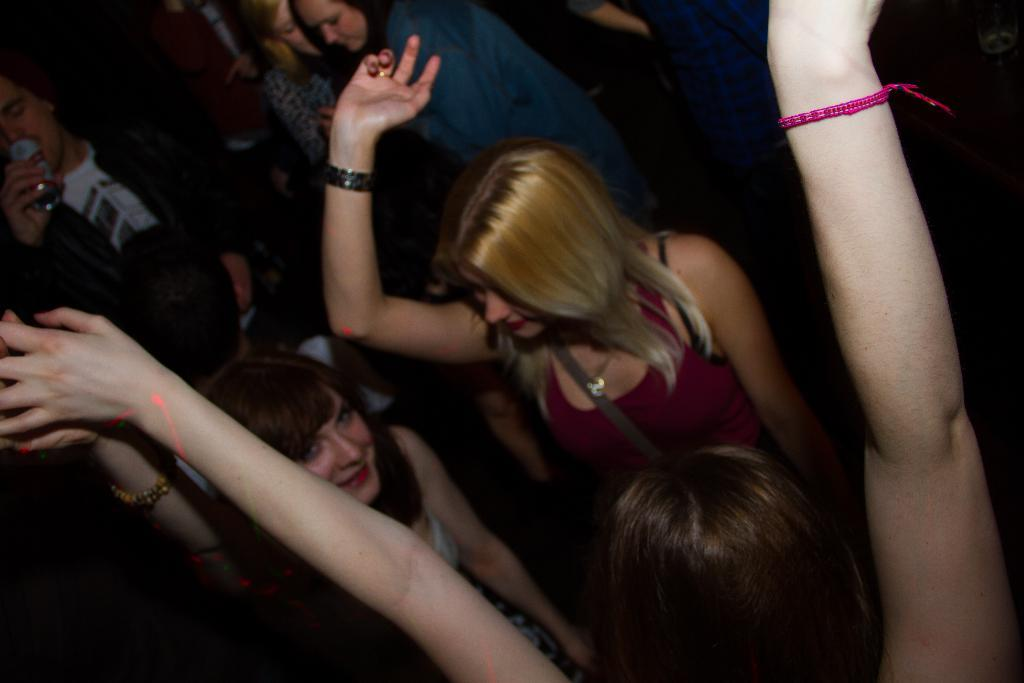Who or what can be seen in the image? There are people in the image. What are the people doing in the image? The people are dancing. How do the people appear to be feeling in the image? The people have smiles on their faces, indicating that they are happy or enjoying themselves. Where is the rabbit performing an operation on the worm in the image? There is no rabbit or worm present in the image, and therefore no such operation is taking place. 